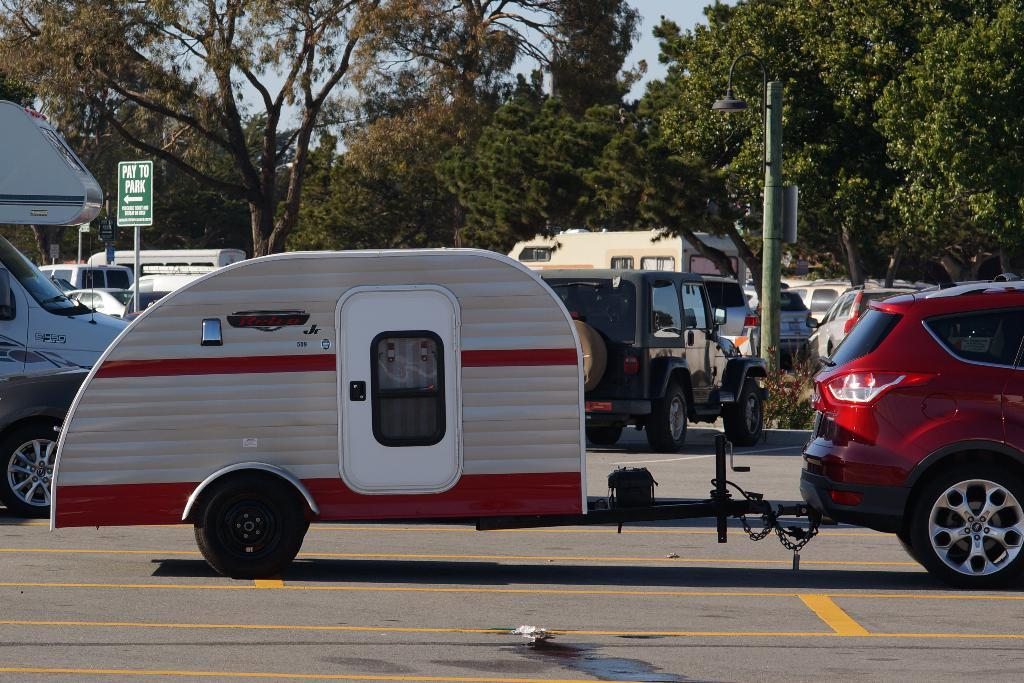Provide a one-sentence caption for the provided image. a green sign behind the teardrop camper says pay to park. 